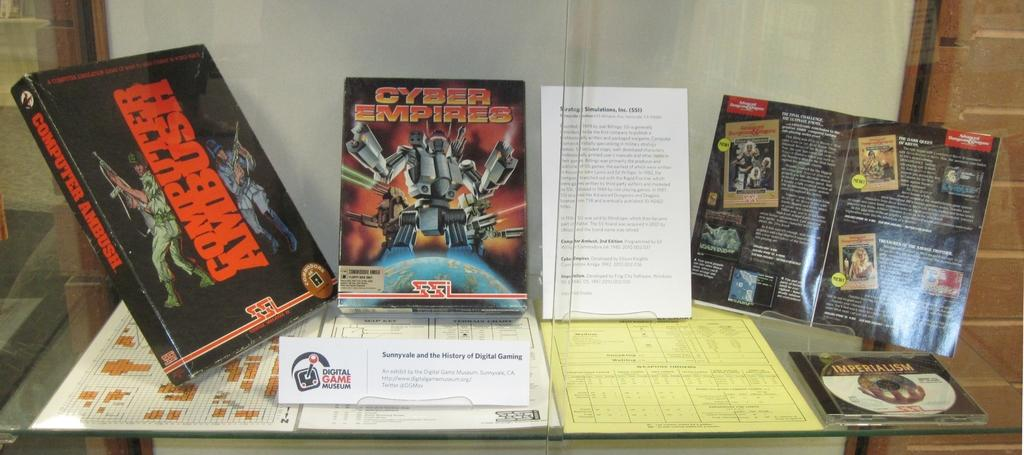<image>
Relay a brief, clear account of the picture shown. Cyber Empire and Computer Ambush Digital Game museum. 